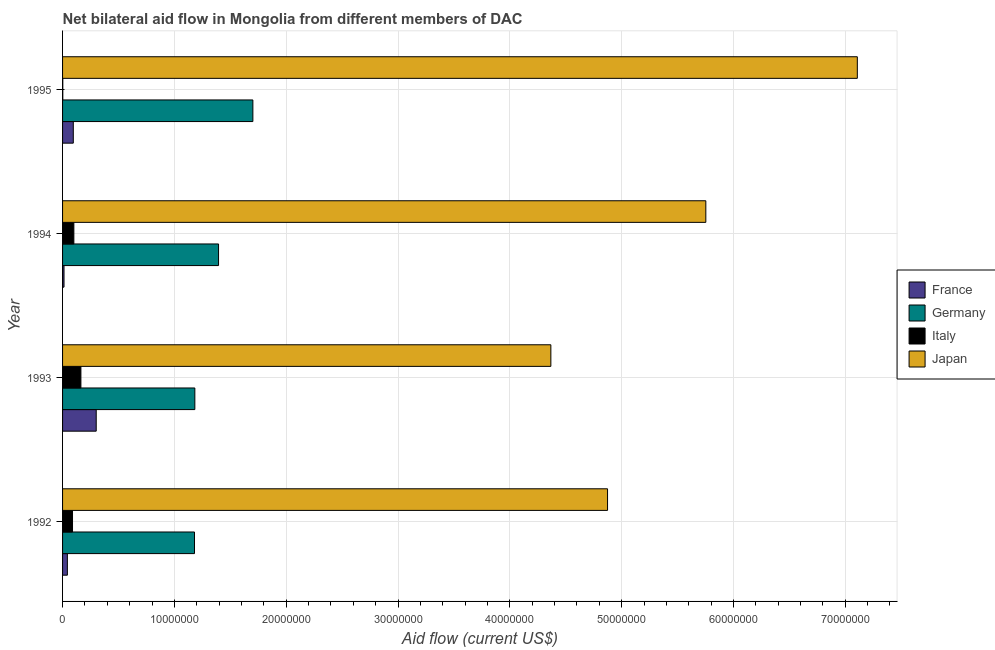Are the number of bars per tick equal to the number of legend labels?
Your answer should be very brief. Yes. How many bars are there on the 2nd tick from the top?
Your response must be concise. 4. In how many cases, is the number of bars for a given year not equal to the number of legend labels?
Offer a terse response. 0. What is the amount of aid given by germany in 1994?
Ensure brevity in your answer.  1.40e+07. Across all years, what is the maximum amount of aid given by italy?
Your answer should be very brief. 1.64e+06. Across all years, what is the minimum amount of aid given by japan?
Provide a short and direct response. 4.37e+07. In which year was the amount of aid given by japan maximum?
Ensure brevity in your answer.  1995. What is the total amount of aid given by germany in the graph?
Offer a very short reply. 5.46e+07. What is the difference between the amount of aid given by france in 1993 and that in 1994?
Offer a very short reply. 2.88e+06. What is the difference between the amount of aid given by germany in 1994 and the amount of aid given by japan in 1995?
Give a very brief answer. -5.71e+07. What is the average amount of aid given by japan per year?
Your answer should be compact. 5.53e+07. In the year 1992, what is the difference between the amount of aid given by germany and amount of aid given by japan?
Provide a succinct answer. -3.69e+07. In how many years, is the amount of aid given by germany greater than 34000000 US$?
Provide a short and direct response. 0. What is the ratio of the amount of aid given by germany in 1993 to that in 1994?
Offer a very short reply. 0.85. Is the amount of aid given by italy in 1993 less than that in 1995?
Offer a terse response. No. Is the difference between the amount of aid given by france in 1993 and 1995 greater than the difference between the amount of aid given by italy in 1993 and 1995?
Keep it short and to the point. Yes. What is the difference between the highest and the second highest amount of aid given by france?
Your answer should be compact. 2.05e+06. What is the difference between the highest and the lowest amount of aid given by italy?
Ensure brevity in your answer.  1.62e+06. Is it the case that in every year, the sum of the amount of aid given by germany and amount of aid given by italy is greater than the sum of amount of aid given by japan and amount of aid given by france?
Make the answer very short. Yes. What does the 3rd bar from the bottom in 1992 represents?
Give a very brief answer. Italy. Is it the case that in every year, the sum of the amount of aid given by france and amount of aid given by germany is greater than the amount of aid given by italy?
Provide a succinct answer. Yes. How many bars are there?
Your answer should be compact. 16. How many legend labels are there?
Make the answer very short. 4. How are the legend labels stacked?
Provide a succinct answer. Vertical. What is the title of the graph?
Provide a succinct answer. Net bilateral aid flow in Mongolia from different members of DAC. Does "Trade" appear as one of the legend labels in the graph?
Your response must be concise. No. What is the label or title of the X-axis?
Provide a succinct answer. Aid flow (current US$). What is the label or title of the Y-axis?
Ensure brevity in your answer.  Year. What is the Aid flow (current US$) of France in 1992?
Offer a terse response. 4.30e+05. What is the Aid flow (current US$) of Germany in 1992?
Give a very brief answer. 1.18e+07. What is the Aid flow (current US$) in Italy in 1992?
Your answer should be compact. 8.90e+05. What is the Aid flow (current US$) in Japan in 1992?
Give a very brief answer. 4.87e+07. What is the Aid flow (current US$) of France in 1993?
Ensure brevity in your answer.  3.01e+06. What is the Aid flow (current US$) of Germany in 1993?
Your answer should be very brief. 1.18e+07. What is the Aid flow (current US$) in Italy in 1993?
Your response must be concise. 1.64e+06. What is the Aid flow (current US$) in Japan in 1993?
Offer a terse response. 4.37e+07. What is the Aid flow (current US$) in France in 1994?
Your answer should be compact. 1.30e+05. What is the Aid flow (current US$) of Germany in 1994?
Provide a short and direct response. 1.40e+07. What is the Aid flow (current US$) of Italy in 1994?
Offer a terse response. 1.01e+06. What is the Aid flow (current US$) in Japan in 1994?
Make the answer very short. 5.75e+07. What is the Aid flow (current US$) in France in 1995?
Offer a very short reply. 9.60e+05. What is the Aid flow (current US$) in Germany in 1995?
Your response must be concise. 1.70e+07. What is the Aid flow (current US$) of Italy in 1995?
Ensure brevity in your answer.  2.00e+04. What is the Aid flow (current US$) of Japan in 1995?
Ensure brevity in your answer.  7.11e+07. Across all years, what is the maximum Aid flow (current US$) of France?
Offer a very short reply. 3.01e+06. Across all years, what is the maximum Aid flow (current US$) in Germany?
Offer a very short reply. 1.70e+07. Across all years, what is the maximum Aid flow (current US$) of Italy?
Offer a very short reply. 1.64e+06. Across all years, what is the maximum Aid flow (current US$) of Japan?
Give a very brief answer. 7.11e+07. Across all years, what is the minimum Aid flow (current US$) in Germany?
Your answer should be compact. 1.18e+07. Across all years, what is the minimum Aid flow (current US$) in Japan?
Your response must be concise. 4.37e+07. What is the total Aid flow (current US$) in France in the graph?
Provide a short and direct response. 4.53e+06. What is the total Aid flow (current US$) of Germany in the graph?
Provide a succinct answer. 5.46e+07. What is the total Aid flow (current US$) of Italy in the graph?
Keep it short and to the point. 3.56e+06. What is the total Aid flow (current US$) of Japan in the graph?
Provide a short and direct response. 2.21e+08. What is the difference between the Aid flow (current US$) in France in 1992 and that in 1993?
Ensure brevity in your answer.  -2.58e+06. What is the difference between the Aid flow (current US$) in Germany in 1992 and that in 1993?
Give a very brief answer. -3.00e+04. What is the difference between the Aid flow (current US$) of Italy in 1992 and that in 1993?
Provide a short and direct response. -7.50e+05. What is the difference between the Aid flow (current US$) of Japan in 1992 and that in 1993?
Provide a short and direct response. 5.07e+06. What is the difference between the Aid flow (current US$) in France in 1992 and that in 1994?
Your answer should be compact. 3.00e+05. What is the difference between the Aid flow (current US$) of Germany in 1992 and that in 1994?
Keep it short and to the point. -2.15e+06. What is the difference between the Aid flow (current US$) of Japan in 1992 and that in 1994?
Ensure brevity in your answer.  -8.79e+06. What is the difference between the Aid flow (current US$) in France in 1992 and that in 1995?
Keep it short and to the point. -5.30e+05. What is the difference between the Aid flow (current US$) of Germany in 1992 and that in 1995?
Keep it short and to the point. -5.22e+06. What is the difference between the Aid flow (current US$) in Italy in 1992 and that in 1995?
Ensure brevity in your answer.  8.70e+05. What is the difference between the Aid flow (current US$) of Japan in 1992 and that in 1995?
Offer a terse response. -2.23e+07. What is the difference between the Aid flow (current US$) in France in 1993 and that in 1994?
Keep it short and to the point. 2.88e+06. What is the difference between the Aid flow (current US$) in Germany in 1993 and that in 1994?
Provide a succinct answer. -2.12e+06. What is the difference between the Aid flow (current US$) of Italy in 1993 and that in 1994?
Provide a short and direct response. 6.30e+05. What is the difference between the Aid flow (current US$) of Japan in 1993 and that in 1994?
Ensure brevity in your answer.  -1.39e+07. What is the difference between the Aid flow (current US$) of France in 1993 and that in 1995?
Keep it short and to the point. 2.05e+06. What is the difference between the Aid flow (current US$) of Germany in 1993 and that in 1995?
Your answer should be very brief. -5.19e+06. What is the difference between the Aid flow (current US$) in Italy in 1993 and that in 1995?
Keep it short and to the point. 1.62e+06. What is the difference between the Aid flow (current US$) of Japan in 1993 and that in 1995?
Provide a succinct answer. -2.74e+07. What is the difference between the Aid flow (current US$) in France in 1994 and that in 1995?
Provide a succinct answer. -8.30e+05. What is the difference between the Aid flow (current US$) in Germany in 1994 and that in 1995?
Your response must be concise. -3.07e+06. What is the difference between the Aid flow (current US$) in Italy in 1994 and that in 1995?
Ensure brevity in your answer.  9.90e+05. What is the difference between the Aid flow (current US$) of Japan in 1994 and that in 1995?
Offer a very short reply. -1.36e+07. What is the difference between the Aid flow (current US$) in France in 1992 and the Aid flow (current US$) in Germany in 1993?
Give a very brief answer. -1.14e+07. What is the difference between the Aid flow (current US$) of France in 1992 and the Aid flow (current US$) of Italy in 1993?
Give a very brief answer. -1.21e+06. What is the difference between the Aid flow (current US$) in France in 1992 and the Aid flow (current US$) in Japan in 1993?
Ensure brevity in your answer.  -4.32e+07. What is the difference between the Aid flow (current US$) of Germany in 1992 and the Aid flow (current US$) of Italy in 1993?
Provide a short and direct response. 1.02e+07. What is the difference between the Aid flow (current US$) of Germany in 1992 and the Aid flow (current US$) of Japan in 1993?
Give a very brief answer. -3.19e+07. What is the difference between the Aid flow (current US$) of Italy in 1992 and the Aid flow (current US$) of Japan in 1993?
Offer a very short reply. -4.28e+07. What is the difference between the Aid flow (current US$) in France in 1992 and the Aid flow (current US$) in Germany in 1994?
Your response must be concise. -1.35e+07. What is the difference between the Aid flow (current US$) in France in 1992 and the Aid flow (current US$) in Italy in 1994?
Provide a succinct answer. -5.80e+05. What is the difference between the Aid flow (current US$) in France in 1992 and the Aid flow (current US$) in Japan in 1994?
Provide a succinct answer. -5.71e+07. What is the difference between the Aid flow (current US$) in Germany in 1992 and the Aid flow (current US$) in Italy in 1994?
Provide a short and direct response. 1.08e+07. What is the difference between the Aid flow (current US$) in Germany in 1992 and the Aid flow (current US$) in Japan in 1994?
Your response must be concise. -4.57e+07. What is the difference between the Aid flow (current US$) of Italy in 1992 and the Aid flow (current US$) of Japan in 1994?
Your response must be concise. -5.66e+07. What is the difference between the Aid flow (current US$) in France in 1992 and the Aid flow (current US$) in Germany in 1995?
Keep it short and to the point. -1.66e+07. What is the difference between the Aid flow (current US$) in France in 1992 and the Aid flow (current US$) in Italy in 1995?
Provide a short and direct response. 4.10e+05. What is the difference between the Aid flow (current US$) of France in 1992 and the Aid flow (current US$) of Japan in 1995?
Your response must be concise. -7.06e+07. What is the difference between the Aid flow (current US$) of Germany in 1992 and the Aid flow (current US$) of Italy in 1995?
Your answer should be compact. 1.18e+07. What is the difference between the Aid flow (current US$) of Germany in 1992 and the Aid flow (current US$) of Japan in 1995?
Keep it short and to the point. -5.93e+07. What is the difference between the Aid flow (current US$) in Italy in 1992 and the Aid flow (current US$) in Japan in 1995?
Make the answer very short. -7.02e+07. What is the difference between the Aid flow (current US$) of France in 1993 and the Aid flow (current US$) of Germany in 1994?
Your response must be concise. -1.09e+07. What is the difference between the Aid flow (current US$) in France in 1993 and the Aid flow (current US$) in Japan in 1994?
Give a very brief answer. -5.45e+07. What is the difference between the Aid flow (current US$) of Germany in 1993 and the Aid flow (current US$) of Italy in 1994?
Provide a short and direct response. 1.08e+07. What is the difference between the Aid flow (current US$) in Germany in 1993 and the Aid flow (current US$) in Japan in 1994?
Offer a terse response. -4.57e+07. What is the difference between the Aid flow (current US$) of Italy in 1993 and the Aid flow (current US$) of Japan in 1994?
Provide a short and direct response. -5.59e+07. What is the difference between the Aid flow (current US$) in France in 1993 and the Aid flow (current US$) in Germany in 1995?
Offer a very short reply. -1.40e+07. What is the difference between the Aid flow (current US$) of France in 1993 and the Aid flow (current US$) of Italy in 1995?
Your answer should be compact. 2.99e+06. What is the difference between the Aid flow (current US$) in France in 1993 and the Aid flow (current US$) in Japan in 1995?
Offer a terse response. -6.81e+07. What is the difference between the Aid flow (current US$) of Germany in 1993 and the Aid flow (current US$) of Italy in 1995?
Offer a terse response. 1.18e+07. What is the difference between the Aid flow (current US$) in Germany in 1993 and the Aid flow (current US$) in Japan in 1995?
Keep it short and to the point. -5.92e+07. What is the difference between the Aid flow (current US$) in Italy in 1993 and the Aid flow (current US$) in Japan in 1995?
Provide a succinct answer. -6.94e+07. What is the difference between the Aid flow (current US$) of France in 1994 and the Aid flow (current US$) of Germany in 1995?
Make the answer very short. -1.69e+07. What is the difference between the Aid flow (current US$) of France in 1994 and the Aid flow (current US$) of Japan in 1995?
Your answer should be very brief. -7.10e+07. What is the difference between the Aid flow (current US$) in Germany in 1994 and the Aid flow (current US$) in Italy in 1995?
Ensure brevity in your answer.  1.39e+07. What is the difference between the Aid flow (current US$) in Germany in 1994 and the Aid flow (current US$) in Japan in 1995?
Offer a terse response. -5.71e+07. What is the difference between the Aid flow (current US$) of Italy in 1994 and the Aid flow (current US$) of Japan in 1995?
Offer a terse response. -7.01e+07. What is the average Aid flow (current US$) in France per year?
Your answer should be compact. 1.13e+06. What is the average Aid flow (current US$) in Germany per year?
Your answer should be compact. 1.36e+07. What is the average Aid flow (current US$) in Italy per year?
Provide a short and direct response. 8.90e+05. What is the average Aid flow (current US$) of Japan per year?
Your answer should be very brief. 5.53e+07. In the year 1992, what is the difference between the Aid flow (current US$) in France and Aid flow (current US$) in Germany?
Your answer should be very brief. -1.14e+07. In the year 1992, what is the difference between the Aid flow (current US$) of France and Aid flow (current US$) of Italy?
Keep it short and to the point. -4.60e+05. In the year 1992, what is the difference between the Aid flow (current US$) of France and Aid flow (current US$) of Japan?
Offer a terse response. -4.83e+07. In the year 1992, what is the difference between the Aid flow (current US$) in Germany and Aid flow (current US$) in Italy?
Ensure brevity in your answer.  1.09e+07. In the year 1992, what is the difference between the Aid flow (current US$) in Germany and Aid flow (current US$) in Japan?
Ensure brevity in your answer.  -3.69e+07. In the year 1992, what is the difference between the Aid flow (current US$) in Italy and Aid flow (current US$) in Japan?
Your response must be concise. -4.78e+07. In the year 1993, what is the difference between the Aid flow (current US$) of France and Aid flow (current US$) of Germany?
Your answer should be compact. -8.82e+06. In the year 1993, what is the difference between the Aid flow (current US$) in France and Aid flow (current US$) in Italy?
Your answer should be very brief. 1.37e+06. In the year 1993, what is the difference between the Aid flow (current US$) in France and Aid flow (current US$) in Japan?
Your response must be concise. -4.07e+07. In the year 1993, what is the difference between the Aid flow (current US$) in Germany and Aid flow (current US$) in Italy?
Your answer should be very brief. 1.02e+07. In the year 1993, what is the difference between the Aid flow (current US$) in Germany and Aid flow (current US$) in Japan?
Offer a very short reply. -3.18e+07. In the year 1993, what is the difference between the Aid flow (current US$) in Italy and Aid flow (current US$) in Japan?
Provide a succinct answer. -4.20e+07. In the year 1994, what is the difference between the Aid flow (current US$) in France and Aid flow (current US$) in Germany?
Your answer should be compact. -1.38e+07. In the year 1994, what is the difference between the Aid flow (current US$) of France and Aid flow (current US$) of Italy?
Your answer should be very brief. -8.80e+05. In the year 1994, what is the difference between the Aid flow (current US$) in France and Aid flow (current US$) in Japan?
Give a very brief answer. -5.74e+07. In the year 1994, what is the difference between the Aid flow (current US$) of Germany and Aid flow (current US$) of Italy?
Your answer should be compact. 1.29e+07. In the year 1994, what is the difference between the Aid flow (current US$) of Germany and Aid flow (current US$) of Japan?
Your response must be concise. -4.36e+07. In the year 1994, what is the difference between the Aid flow (current US$) in Italy and Aid flow (current US$) in Japan?
Offer a terse response. -5.65e+07. In the year 1995, what is the difference between the Aid flow (current US$) of France and Aid flow (current US$) of Germany?
Offer a terse response. -1.61e+07. In the year 1995, what is the difference between the Aid flow (current US$) in France and Aid flow (current US$) in Italy?
Provide a short and direct response. 9.40e+05. In the year 1995, what is the difference between the Aid flow (current US$) in France and Aid flow (current US$) in Japan?
Keep it short and to the point. -7.01e+07. In the year 1995, what is the difference between the Aid flow (current US$) in Germany and Aid flow (current US$) in Italy?
Your answer should be compact. 1.70e+07. In the year 1995, what is the difference between the Aid flow (current US$) in Germany and Aid flow (current US$) in Japan?
Offer a terse response. -5.41e+07. In the year 1995, what is the difference between the Aid flow (current US$) in Italy and Aid flow (current US$) in Japan?
Make the answer very short. -7.11e+07. What is the ratio of the Aid flow (current US$) of France in 1992 to that in 1993?
Your answer should be compact. 0.14. What is the ratio of the Aid flow (current US$) in Italy in 1992 to that in 1993?
Your answer should be compact. 0.54. What is the ratio of the Aid flow (current US$) of Japan in 1992 to that in 1993?
Give a very brief answer. 1.12. What is the ratio of the Aid flow (current US$) of France in 1992 to that in 1994?
Ensure brevity in your answer.  3.31. What is the ratio of the Aid flow (current US$) in Germany in 1992 to that in 1994?
Provide a succinct answer. 0.85. What is the ratio of the Aid flow (current US$) of Italy in 1992 to that in 1994?
Offer a terse response. 0.88. What is the ratio of the Aid flow (current US$) in Japan in 1992 to that in 1994?
Provide a short and direct response. 0.85. What is the ratio of the Aid flow (current US$) in France in 1992 to that in 1995?
Offer a terse response. 0.45. What is the ratio of the Aid flow (current US$) in Germany in 1992 to that in 1995?
Make the answer very short. 0.69. What is the ratio of the Aid flow (current US$) in Italy in 1992 to that in 1995?
Provide a short and direct response. 44.5. What is the ratio of the Aid flow (current US$) of Japan in 1992 to that in 1995?
Your answer should be compact. 0.69. What is the ratio of the Aid flow (current US$) in France in 1993 to that in 1994?
Your response must be concise. 23.15. What is the ratio of the Aid flow (current US$) in Germany in 1993 to that in 1994?
Keep it short and to the point. 0.85. What is the ratio of the Aid flow (current US$) of Italy in 1993 to that in 1994?
Keep it short and to the point. 1.62. What is the ratio of the Aid flow (current US$) in Japan in 1993 to that in 1994?
Provide a short and direct response. 0.76. What is the ratio of the Aid flow (current US$) of France in 1993 to that in 1995?
Make the answer very short. 3.14. What is the ratio of the Aid flow (current US$) in Germany in 1993 to that in 1995?
Make the answer very short. 0.7. What is the ratio of the Aid flow (current US$) in Italy in 1993 to that in 1995?
Provide a succinct answer. 82. What is the ratio of the Aid flow (current US$) in Japan in 1993 to that in 1995?
Your answer should be very brief. 0.61. What is the ratio of the Aid flow (current US$) in France in 1994 to that in 1995?
Offer a very short reply. 0.14. What is the ratio of the Aid flow (current US$) of Germany in 1994 to that in 1995?
Make the answer very short. 0.82. What is the ratio of the Aid flow (current US$) of Italy in 1994 to that in 1995?
Your answer should be very brief. 50.5. What is the ratio of the Aid flow (current US$) of Japan in 1994 to that in 1995?
Provide a short and direct response. 0.81. What is the difference between the highest and the second highest Aid flow (current US$) in France?
Ensure brevity in your answer.  2.05e+06. What is the difference between the highest and the second highest Aid flow (current US$) of Germany?
Offer a terse response. 3.07e+06. What is the difference between the highest and the second highest Aid flow (current US$) of Italy?
Offer a terse response. 6.30e+05. What is the difference between the highest and the second highest Aid flow (current US$) in Japan?
Ensure brevity in your answer.  1.36e+07. What is the difference between the highest and the lowest Aid flow (current US$) in France?
Provide a succinct answer. 2.88e+06. What is the difference between the highest and the lowest Aid flow (current US$) of Germany?
Make the answer very short. 5.22e+06. What is the difference between the highest and the lowest Aid flow (current US$) of Italy?
Provide a succinct answer. 1.62e+06. What is the difference between the highest and the lowest Aid flow (current US$) in Japan?
Your response must be concise. 2.74e+07. 